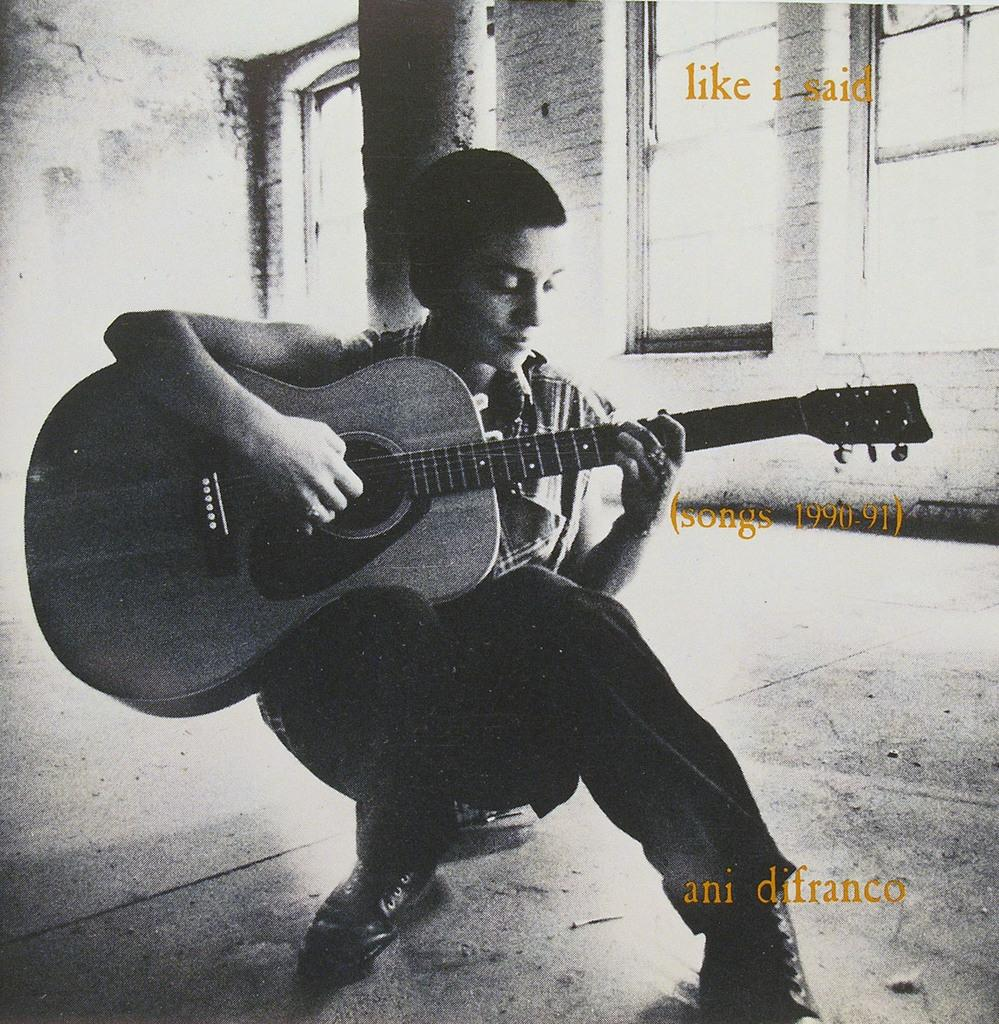What is the boy in the image doing? The boy is sitting and playing the guitar in the image. What object is the boy holding? The boy is holding a guitar. What is located behind the boy in the image? There is a pillar behind the boy. What can be seen in the right corner of the image? There are windows in the right corner of the image. What type of footwear is the boy wearing? The boy is wearing shoes. What story is the boy telling with the sign in the image? There is no sign present in the image, so no story can be told with a sign. Is the boy being attacked by any creatures in the image? There are no creatures or any indication of an attack in the image. 